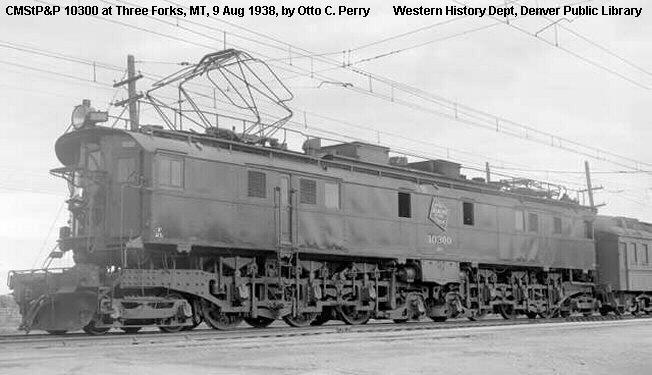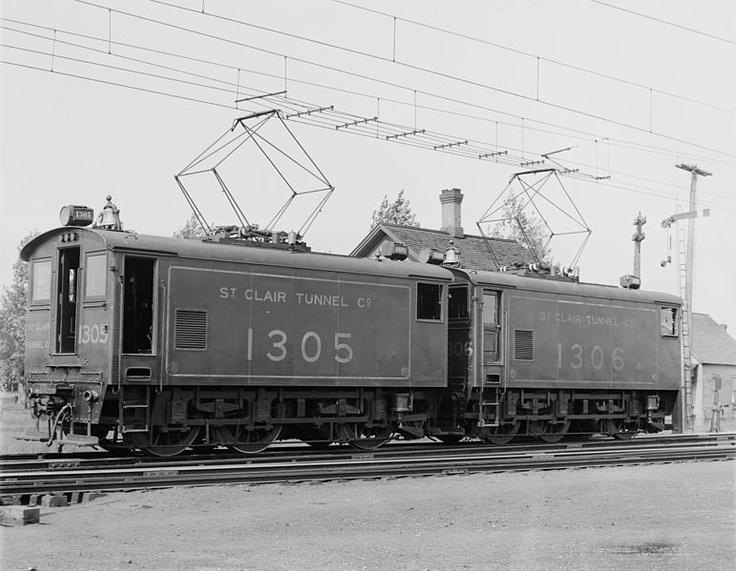The first image is the image on the left, the second image is the image on the right. Examine the images to the left and right. Is the description "The two trains pictured head in opposite directions, and the train on the right has three windows across the front." accurate? Answer yes or no. No. 